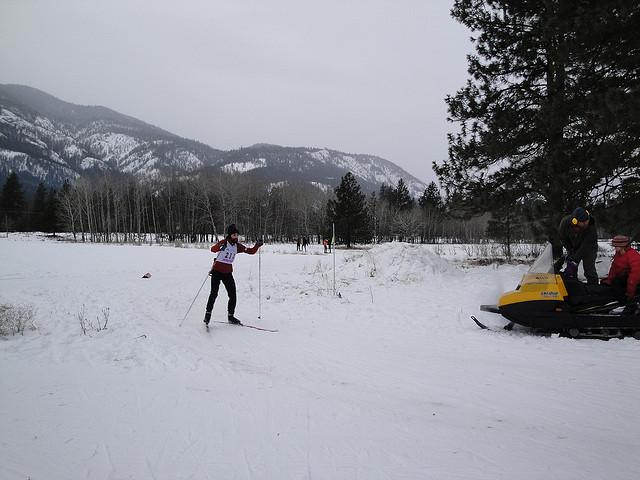What is the name of the yellow vehicle the man in red is on?

Choices:
A) snow scooter
B) snowmobile
C) snow quad
D) ski truck snowmobile 